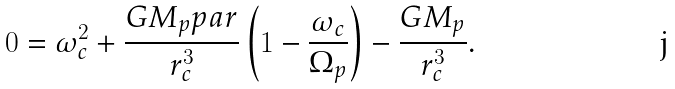<formula> <loc_0><loc_0><loc_500><loc_500>0 = \omega _ { c } ^ { 2 } + \frac { G M _ { p } \L p a r } { r _ { c } ^ { 3 } } \left ( 1 - \frac { \omega _ { c } } { \Omega _ { p } } \right ) - \frac { G M _ { p } } { r _ { c } ^ { 3 } } .</formula> 